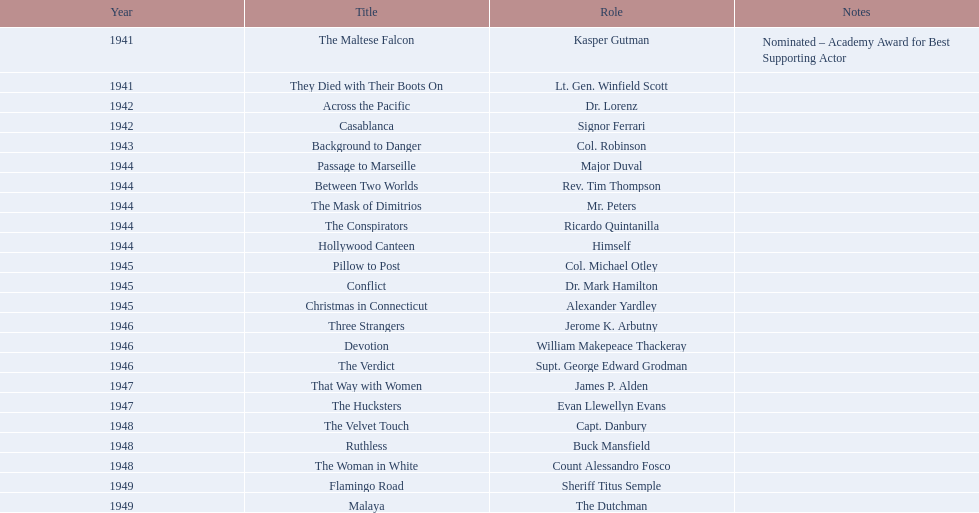Would you be able to parse every entry in this table? {'header': ['Year', 'Title', 'Role', 'Notes'], 'rows': [['1941', 'The Maltese Falcon', 'Kasper Gutman', 'Nominated – Academy Award for Best Supporting Actor'], ['1941', 'They Died with Their Boots On', 'Lt. Gen. Winfield Scott', ''], ['1942', 'Across the Pacific', 'Dr. Lorenz', ''], ['1942', 'Casablanca', 'Signor Ferrari', ''], ['1943', 'Background to Danger', 'Col. Robinson', ''], ['1944', 'Passage to Marseille', 'Major Duval', ''], ['1944', 'Between Two Worlds', 'Rev. Tim Thompson', ''], ['1944', 'The Mask of Dimitrios', 'Mr. Peters', ''], ['1944', 'The Conspirators', 'Ricardo Quintanilla', ''], ['1944', 'Hollywood Canteen', 'Himself', ''], ['1945', 'Pillow to Post', 'Col. Michael Otley', ''], ['1945', 'Conflict', 'Dr. Mark Hamilton', ''], ['1945', 'Christmas in Connecticut', 'Alexander Yardley', ''], ['1946', 'Three Strangers', 'Jerome K. Arbutny', ''], ['1946', 'Devotion', 'William Makepeace Thackeray', ''], ['1946', 'The Verdict', 'Supt. George Edward Grodman', ''], ['1947', 'That Way with Women', 'James P. Alden', ''], ['1947', 'The Hucksters', 'Evan Llewellyn Evans', ''], ['1948', 'The Velvet Touch', 'Capt. Danbury', ''], ['1948', 'Ruthless', 'Buck Mansfield', ''], ['1948', 'The Woman in White', 'Count Alessandro Fosco', ''], ['1949', 'Flamingo Road', 'Sheriff Titus Semple', ''], ['1949', 'Malaya', 'The Dutchman', '']]} What are all the films sydney greenstreet appeared in? The Maltese Falcon, They Died with Their Boots On, Across the Pacific, Casablanca, Background to Danger, Passage to Marseille, Between Two Worlds, The Mask of Dimitrios, The Conspirators, Hollywood Canteen, Pillow to Post, Conflict, Christmas in Connecticut, Three Strangers, Devotion, The Verdict, That Way with Women, The Hucksters, The Velvet Touch, Ruthless, The Woman in White, Flamingo Road, Malaya. What are all the title remarks? Nominated – Academy Award for Best Supporting Actor. Which movie received the award? The Maltese Falcon. 